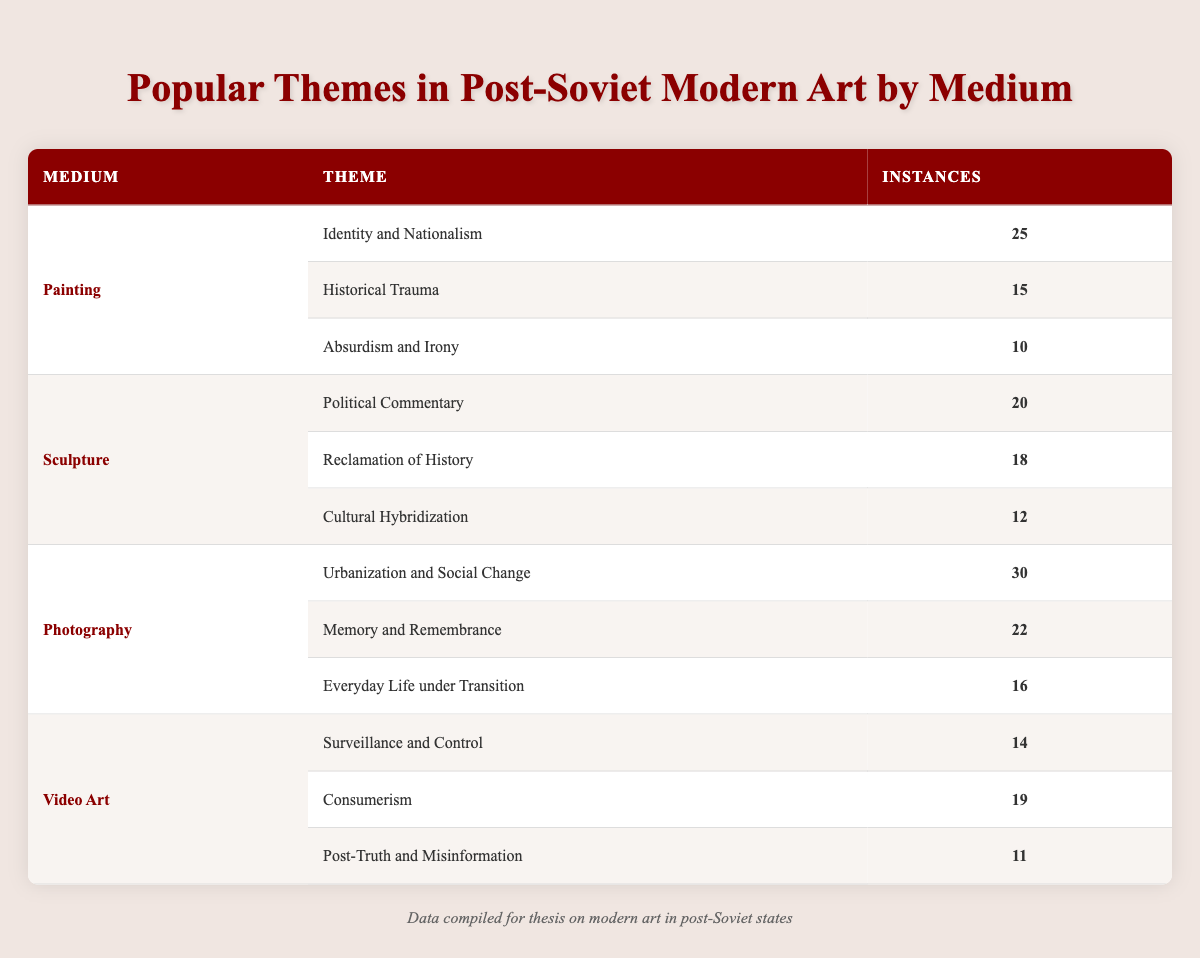What is the most common theme in Painting? According to the table, the theme with the highest number of instances in Painting is "Identity and Nationalism," which has 25 instances.
Answer: Identity and Nationalism How many instances of "Memory and Remembrance" are there in Photography? The table shows that "Memory and Remembrance" has 22 instances in the Photography medium.
Answer: 22 Is "Cultural Hybridization" mentioned as a theme in Sculpture? Yes, the table includes "Cultural Hybridization" as a theme under the Sculpture medium, with 12 instances.
Answer: Yes What is the total number of instances for Video Art themes? To find the total for Video Art, add the instances for each theme: 14 (Surveillance and Control) + 19 (Consumerism) + 11 (Post-Truth and Misinformation) = 44.
Answer: 44 Which medium has the highest number of instances for Political Commentary? The only instance of "Political Commentary" is under Sculpture, which has 20 instances; thus, Sculpture has the highest number for this theme.
Answer: Sculpture What is the average number of instances for themes in Painting? The total number of instances in Painting is 25 (Identity and Nationalism) + 15 (Historical Trauma) + 10 (Absurdism and Irony) = 50. There are 3 themes, so the average is 50/3 = 16.67.
Answer: 16.67 Does Photography have more instances than Sculpture in total? Adding the instances for Photography gives us 30 (Urbanization and Social Change) + 22 (Memory and Remembrance) + 16 (Everyday Life under Transition) = 68, while Sculpture has 20 + 18 + 12 = 50. Since 68 > 50, the answer is yes, Photography has more instances than Sculpture.
Answer: Yes What is the difference in instances between the highest and lowest theme in Sculpture? The highest theme in Sculpture is "Political Commentary" with 20 instances, and the lowest is "Cultural Hybridization" with 12 instances. The difference is 20 - 12 = 8.
Answer: 8 Which medium includes a theme related to "Urbanization and Social Change"? The table indicates that "Urbanization and Social Change" is a theme under the Photography medium, with 30 instances.
Answer: Photography 